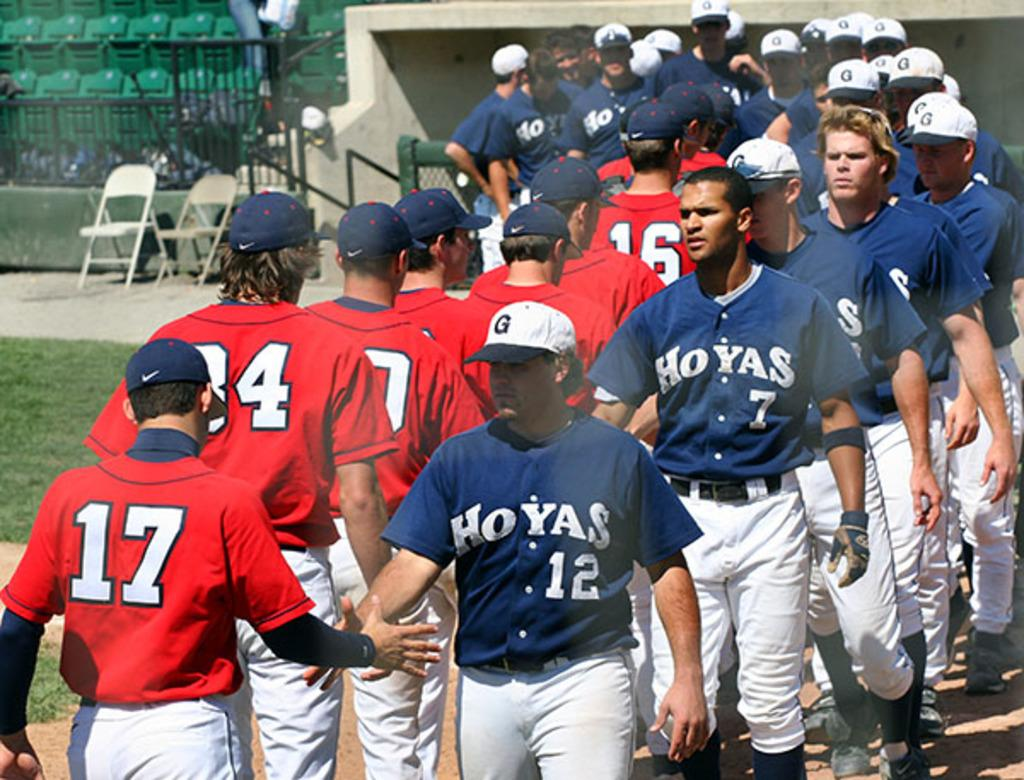<image>
Write a terse but informative summary of the picture. A few baseball teams are on the field with one team being HOYAS. 